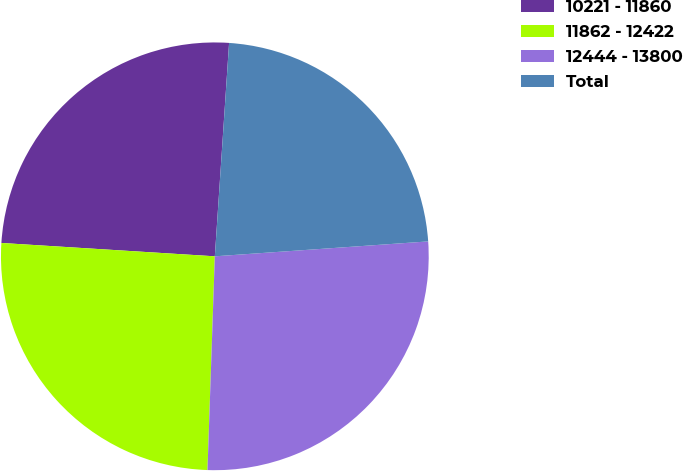<chart> <loc_0><loc_0><loc_500><loc_500><pie_chart><fcel>10221 - 11860<fcel>11862 - 12422<fcel>12444 - 13800<fcel>Total<nl><fcel>25.07%<fcel>25.45%<fcel>26.66%<fcel>22.83%<nl></chart> 